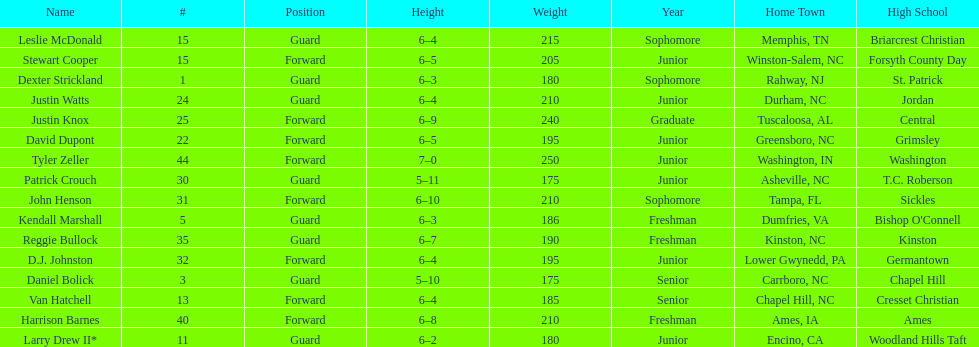How many players play a position other than guard? 8. 